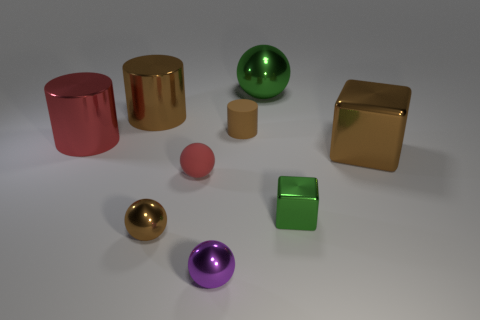Subtract 1 balls. How many balls are left? 3 Subtract all gray spheres. Subtract all blue cylinders. How many spheres are left? 4 Subtract all cylinders. How many objects are left? 6 Add 4 small cubes. How many small cubes exist? 5 Subtract 0 cyan spheres. How many objects are left? 9 Subtract all shiny things. Subtract all purple shiny objects. How many objects are left? 1 Add 9 purple things. How many purple things are left? 10 